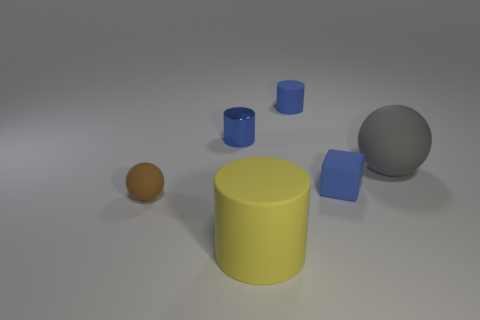There is a brown rubber thing; does it have the same size as the sphere right of the block?
Your answer should be compact. No. The rubber ball in front of the matte ball that is behind the small brown matte object is what color?
Your response must be concise. Brown. How many objects are blue things that are behind the matte cube or small blue things that are in front of the blue rubber cylinder?
Keep it short and to the point. 3. Does the shiny object have the same size as the yellow matte thing?
Provide a succinct answer. No. Does the object in front of the brown matte ball have the same shape as the small blue thing in front of the gray object?
Your answer should be very brief. No. What size is the cube?
Offer a terse response. Small. The small blue object that is in front of the matte ball behind the matte sphere that is left of the blue matte cylinder is made of what material?
Provide a succinct answer. Rubber. What number of other things are there of the same color as the matte block?
Make the answer very short. 2. How many brown objects are rubber blocks or big balls?
Ensure brevity in your answer.  0. There is a blue cylinder that is on the right side of the yellow matte cylinder; what is its material?
Provide a short and direct response. Rubber. 